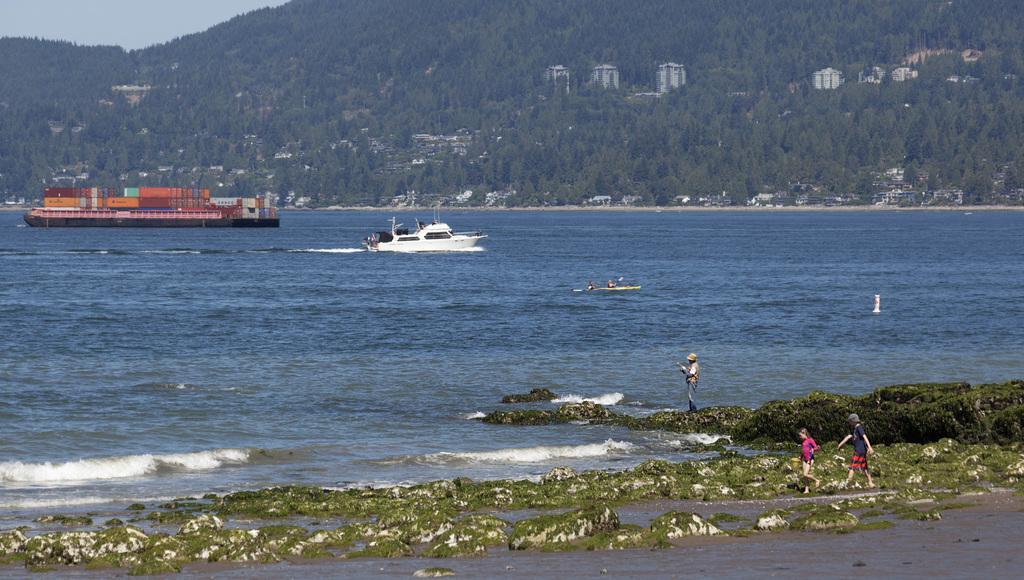Describe this image in one or two sentences. In this image I can see few boats on the water and I can also see few containers on the boat. In front I can see three persons. In the background I can see few trees in green color, buildings and the sky is in white color. 